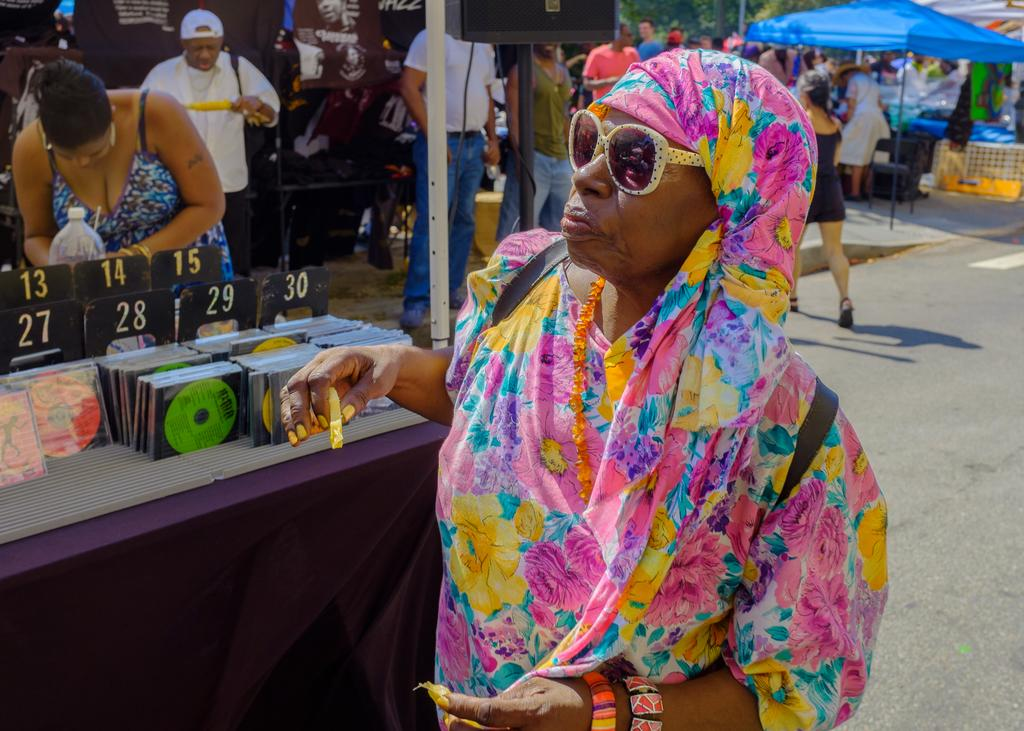Who is the main subject in the image? There is a woman in the image. What is the woman wearing? The woman is wearing a colorful saree. Are there any accessories visible on the woman? Yes, the woman is wearing spectacles. What can be seen in the background of the image? There are many people in the background of the image, and they are standing in front of stalls. What type of cabbage can be seen growing in the background of the image? There is no cabbage present in the image; the background features people standing in front of stalls. 